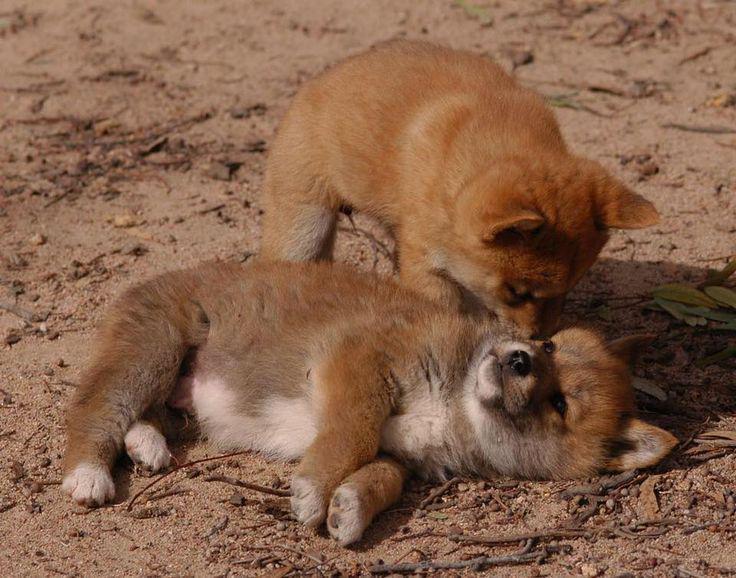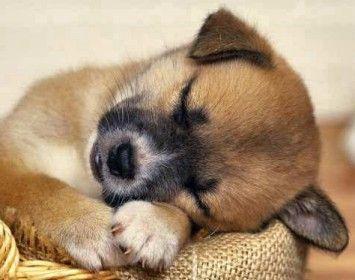The first image is the image on the left, the second image is the image on the right. For the images displayed, is the sentence "Each image shows one reclining orange dingo with its eyes closed and its head down instead of raised, and no dingos are tiny pups." factually correct? Answer yes or no. No. The first image is the image on the left, the second image is the image on the right. Evaluate the accuracy of this statement regarding the images: "One of the images shows a dog laying near a tree.". Is it true? Answer yes or no. No. 